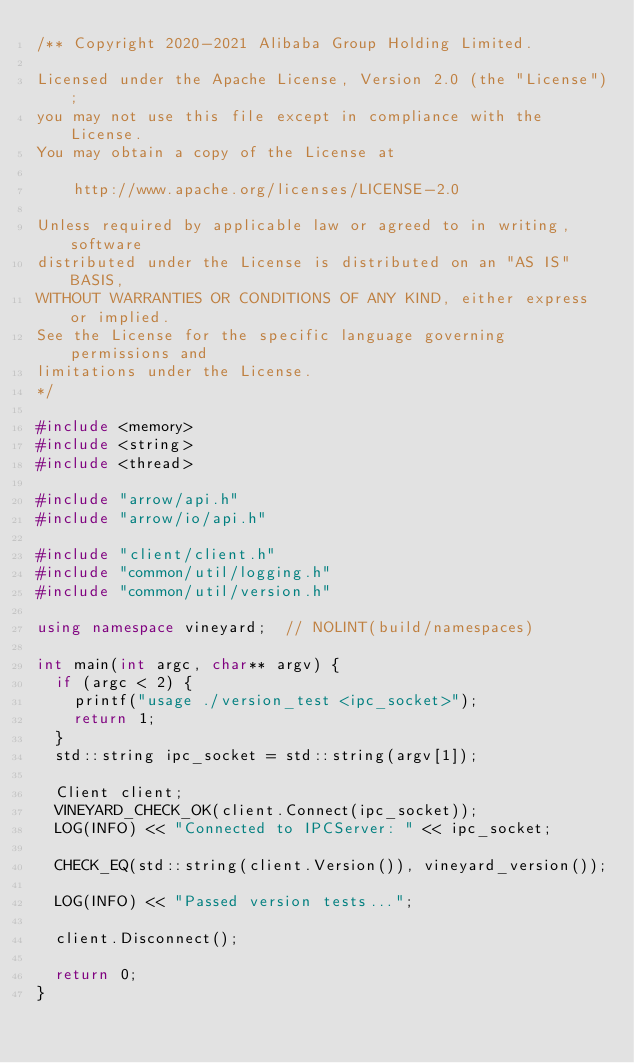<code> <loc_0><loc_0><loc_500><loc_500><_C++_>/** Copyright 2020-2021 Alibaba Group Holding Limited.

Licensed under the Apache License, Version 2.0 (the "License");
you may not use this file except in compliance with the License.
You may obtain a copy of the License at

    http://www.apache.org/licenses/LICENSE-2.0

Unless required by applicable law or agreed to in writing, software
distributed under the License is distributed on an "AS IS" BASIS,
WITHOUT WARRANTIES OR CONDITIONS OF ANY KIND, either express or implied.
See the License for the specific language governing permissions and
limitations under the License.
*/

#include <memory>
#include <string>
#include <thread>

#include "arrow/api.h"
#include "arrow/io/api.h"

#include "client/client.h"
#include "common/util/logging.h"
#include "common/util/version.h"

using namespace vineyard;  // NOLINT(build/namespaces)

int main(int argc, char** argv) {
  if (argc < 2) {
    printf("usage ./version_test <ipc_socket>");
    return 1;
  }
  std::string ipc_socket = std::string(argv[1]);

  Client client;
  VINEYARD_CHECK_OK(client.Connect(ipc_socket));
  LOG(INFO) << "Connected to IPCServer: " << ipc_socket;

  CHECK_EQ(std::string(client.Version()), vineyard_version());

  LOG(INFO) << "Passed version tests...";

  client.Disconnect();

  return 0;
}
</code> 